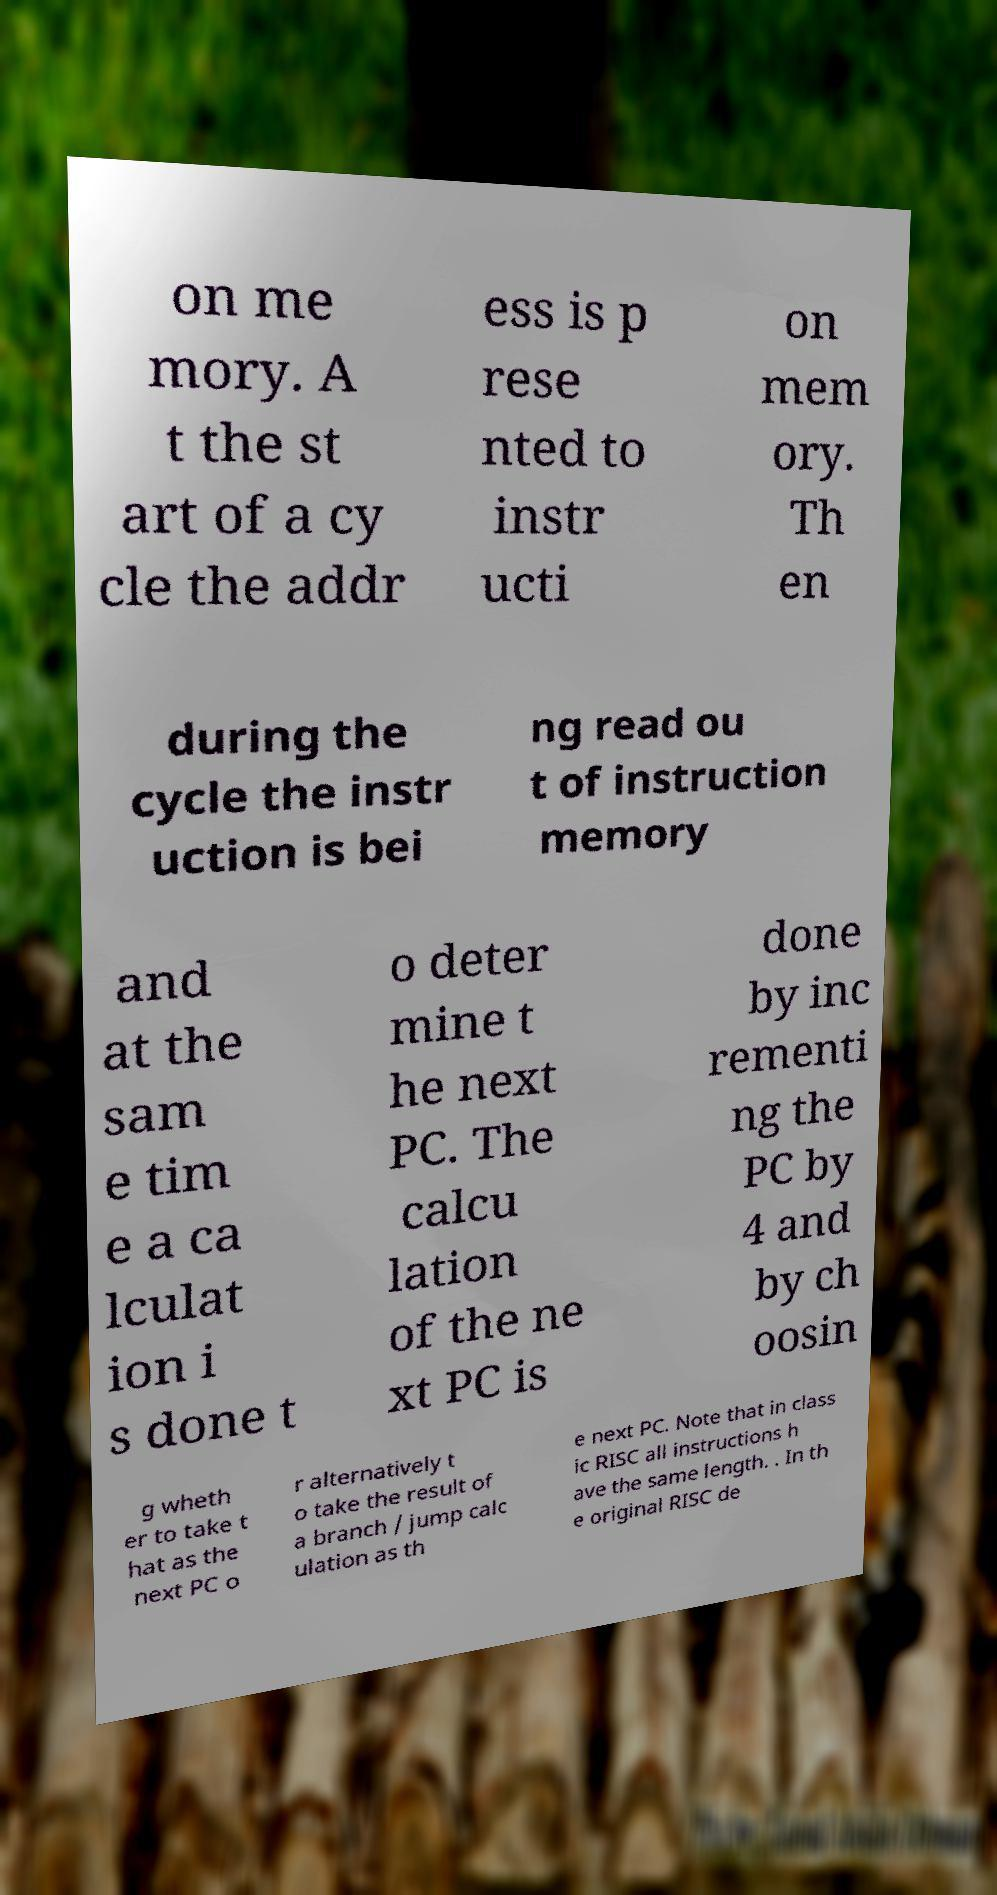Could you extract and type out the text from this image? on me mory. A t the st art of a cy cle the addr ess is p rese nted to instr ucti on mem ory. Th en during the cycle the instr uction is bei ng read ou t of instruction memory and at the sam e tim e a ca lculat ion i s done t o deter mine t he next PC. The calcu lation of the ne xt PC is done by inc rementi ng the PC by 4 and by ch oosin g wheth er to take t hat as the next PC o r alternatively t o take the result of a branch / jump calc ulation as th e next PC. Note that in class ic RISC all instructions h ave the same length. . In th e original RISC de 